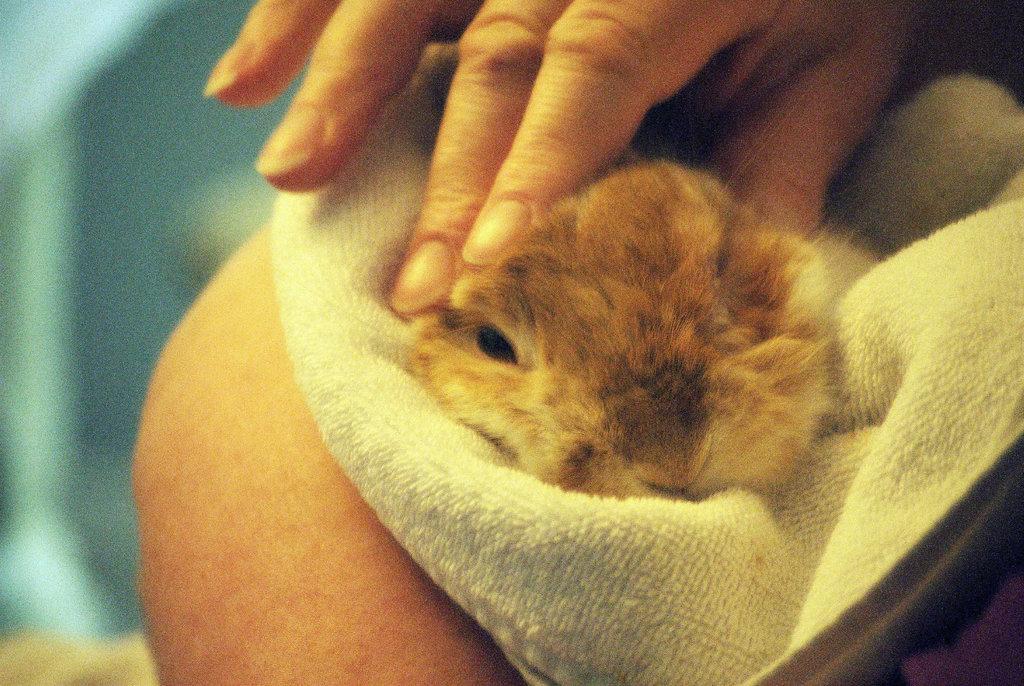Describe this image in one or two sentences. In this picture I can observe an animal. This animal is in brown color. I can observe a human hand in the middle of the picture. The background is completely blurred. 